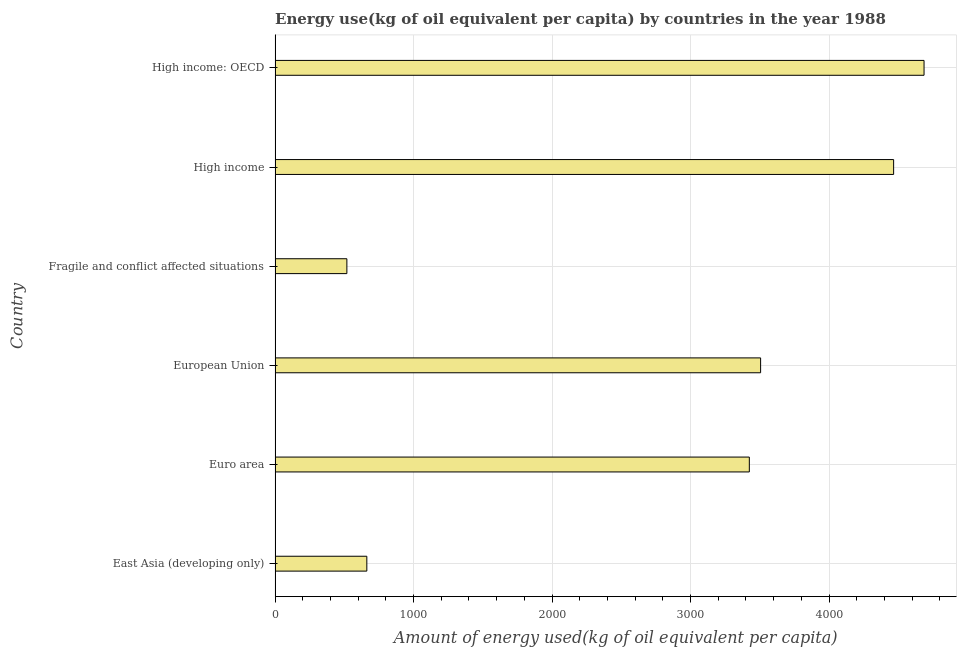Does the graph contain any zero values?
Ensure brevity in your answer.  No. Does the graph contain grids?
Offer a terse response. Yes. What is the title of the graph?
Ensure brevity in your answer.  Energy use(kg of oil equivalent per capita) by countries in the year 1988. What is the label or title of the X-axis?
Ensure brevity in your answer.  Amount of energy used(kg of oil equivalent per capita). What is the label or title of the Y-axis?
Your answer should be very brief. Country. What is the amount of energy used in Euro area?
Give a very brief answer. 3424.38. Across all countries, what is the maximum amount of energy used?
Your answer should be very brief. 4685.9. Across all countries, what is the minimum amount of energy used?
Offer a terse response. 518.38. In which country was the amount of energy used maximum?
Keep it short and to the point. High income: OECD. In which country was the amount of energy used minimum?
Provide a short and direct response. Fragile and conflict affected situations. What is the sum of the amount of energy used?
Make the answer very short. 1.73e+04. What is the difference between the amount of energy used in European Union and Fragile and conflict affected situations?
Your answer should be compact. 2987.45. What is the average amount of energy used per country?
Make the answer very short. 2877.21. What is the median amount of energy used?
Your answer should be very brief. 3465.1. In how many countries, is the amount of energy used greater than 4200 kg?
Offer a terse response. 2. What is the ratio of the amount of energy used in East Asia (developing only) to that in European Union?
Give a very brief answer. 0.19. Is the amount of energy used in Euro area less than that in European Union?
Provide a succinct answer. Yes. What is the difference between the highest and the second highest amount of energy used?
Offer a terse response. 219.59. What is the difference between the highest and the lowest amount of energy used?
Your response must be concise. 4167.52. In how many countries, is the amount of energy used greater than the average amount of energy used taken over all countries?
Ensure brevity in your answer.  4. How many bars are there?
Your answer should be compact. 6. What is the difference between two consecutive major ticks on the X-axis?
Offer a terse response. 1000. What is the Amount of energy used(kg of oil equivalent per capita) in East Asia (developing only)?
Offer a terse response. 662.47. What is the Amount of energy used(kg of oil equivalent per capita) in Euro area?
Ensure brevity in your answer.  3424.38. What is the Amount of energy used(kg of oil equivalent per capita) of European Union?
Provide a short and direct response. 3505.82. What is the Amount of energy used(kg of oil equivalent per capita) in Fragile and conflict affected situations?
Your answer should be compact. 518.38. What is the Amount of energy used(kg of oil equivalent per capita) in High income?
Your answer should be very brief. 4466.3. What is the Amount of energy used(kg of oil equivalent per capita) of High income: OECD?
Make the answer very short. 4685.9. What is the difference between the Amount of energy used(kg of oil equivalent per capita) in East Asia (developing only) and Euro area?
Make the answer very short. -2761.91. What is the difference between the Amount of energy used(kg of oil equivalent per capita) in East Asia (developing only) and European Union?
Make the answer very short. -2843.35. What is the difference between the Amount of energy used(kg of oil equivalent per capita) in East Asia (developing only) and Fragile and conflict affected situations?
Your response must be concise. 144.09. What is the difference between the Amount of energy used(kg of oil equivalent per capita) in East Asia (developing only) and High income?
Offer a very short reply. -3803.83. What is the difference between the Amount of energy used(kg of oil equivalent per capita) in East Asia (developing only) and High income: OECD?
Offer a very short reply. -4023.43. What is the difference between the Amount of energy used(kg of oil equivalent per capita) in Euro area and European Union?
Your answer should be compact. -81.44. What is the difference between the Amount of energy used(kg of oil equivalent per capita) in Euro area and Fragile and conflict affected situations?
Your answer should be very brief. 2906. What is the difference between the Amount of energy used(kg of oil equivalent per capita) in Euro area and High income?
Give a very brief answer. -1041.92. What is the difference between the Amount of energy used(kg of oil equivalent per capita) in Euro area and High income: OECD?
Ensure brevity in your answer.  -1261.52. What is the difference between the Amount of energy used(kg of oil equivalent per capita) in European Union and Fragile and conflict affected situations?
Keep it short and to the point. 2987.44. What is the difference between the Amount of energy used(kg of oil equivalent per capita) in European Union and High income?
Your answer should be very brief. -960.48. What is the difference between the Amount of energy used(kg of oil equivalent per capita) in European Union and High income: OECD?
Offer a very short reply. -1180.08. What is the difference between the Amount of energy used(kg of oil equivalent per capita) in Fragile and conflict affected situations and High income?
Ensure brevity in your answer.  -3947.93. What is the difference between the Amount of energy used(kg of oil equivalent per capita) in Fragile and conflict affected situations and High income: OECD?
Offer a very short reply. -4167.52. What is the difference between the Amount of energy used(kg of oil equivalent per capita) in High income and High income: OECD?
Ensure brevity in your answer.  -219.59. What is the ratio of the Amount of energy used(kg of oil equivalent per capita) in East Asia (developing only) to that in Euro area?
Offer a terse response. 0.19. What is the ratio of the Amount of energy used(kg of oil equivalent per capita) in East Asia (developing only) to that in European Union?
Offer a terse response. 0.19. What is the ratio of the Amount of energy used(kg of oil equivalent per capita) in East Asia (developing only) to that in Fragile and conflict affected situations?
Provide a succinct answer. 1.28. What is the ratio of the Amount of energy used(kg of oil equivalent per capita) in East Asia (developing only) to that in High income?
Your answer should be very brief. 0.15. What is the ratio of the Amount of energy used(kg of oil equivalent per capita) in East Asia (developing only) to that in High income: OECD?
Provide a succinct answer. 0.14. What is the ratio of the Amount of energy used(kg of oil equivalent per capita) in Euro area to that in Fragile and conflict affected situations?
Give a very brief answer. 6.61. What is the ratio of the Amount of energy used(kg of oil equivalent per capita) in Euro area to that in High income?
Offer a terse response. 0.77. What is the ratio of the Amount of energy used(kg of oil equivalent per capita) in Euro area to that in High income: OECD?
Provide a short and direct response. 0.73. What is the ratio of the Amount of energy used(kg of oil equivalent per capita) in European Union to that in Fragile and conflict affected situations?
Keep it short and to the point. 6.76. What is the ratio of the Amount of energy used(kg of oil equivalent per capita) in European Union to that in High income?
Provide a succinct answer. 0.79. What is the ratio of the Amount of energy used(kg of oil equivalent per capita) in European Union to that in High income: OECD?
Provide a succinct answer. 0.75. What is the ratio of the Amount of energy used(kg of oil equivalent per capita) in Fragile and conflict affected situations to that in High income?
Your response must be concise. 0.12. What is the ratio of the Amount of energy used(kg of oil equivalent per capita) in Fragile and conflict affected situations to that in High income: OECD?
Your answer should be very brief. 0.11. What is the ratio of the Amount of energy used(kg of oil equivalent per capita) in High income to that in High income: OECD?
Give a very brief answer. 0.95. 